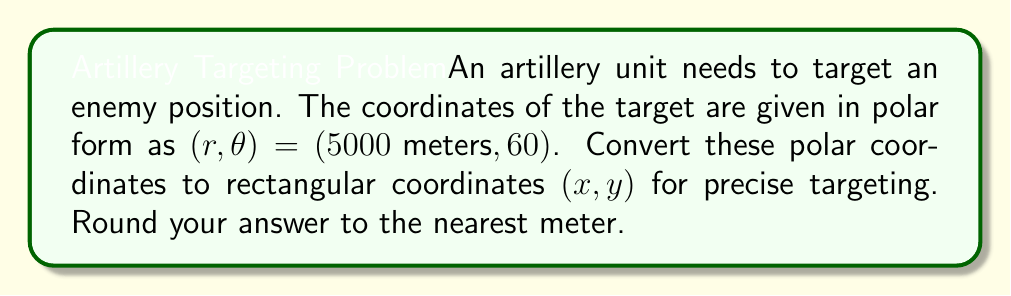Can you solve this math problem? To convert polar coordinates $(r, \theta)$ to rectangular coordinates $(x, y)$, we use the following formulas:

$$x = r \cos(\theta)$$
$$y = r \sin(\theta)$$

Given:
$r = 5000 \text{ meters}$
$\theta = 60°$

Step 1: Calculate $x$
$$x = r \cos(\theta)$$
$$x = 5000 \cos(60°)$$
$$x = 5000 \cdot 0.5 = 2500 \text{ meters}$$

Step 2: Calculate $y$
$$y = r \sin(\theta)$$
$$y = 5000 \sin(60°)$$
$$y = 5000 \cdot \frac{\sqrt{3}}{2} \approx 4330.13 \text{ meters}$$

Step 3: Round the results to the nearest meter
$x = 2500 \text{ meters}$
$y = 4330 \text{ meters}$

[asy]
unitsize(0.0002cm);
draw((-1000,0)--(6000,0),arrow=Arrow(TeXHead));
draw((0,-1000)--(0,5000),arrow=Arrow(TeXHead));
draw((0,0)--(2500,4330),arrow=Arrow(TeXHead));
dot((2500,4330));
label("(2500, 4330)", (2700,4530), NE);
label("5000 m", (1250,2165), NW);
draw(arc((0,0),500,0,60));
label("60°", (400,100), NE);
label("x", (6000,-200), E);
label("y", (-200,5000), N);
[/asy]
Answer: The rectangular coordinates are $(2500 \text{ meters}, 4330 \text{ meters})$. 